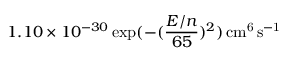Convert formula to latex. <formula><loc_0><loc_0><loc_500><loc_500>1 . 1 0 \times 1 0 ^ { - 3 0 } \exp ( - ( \frac { E / n } { 6 5 } ) ^ { 2 } ) \, c m ^ { 6 } \, s ^ { - 1 }</formula> 